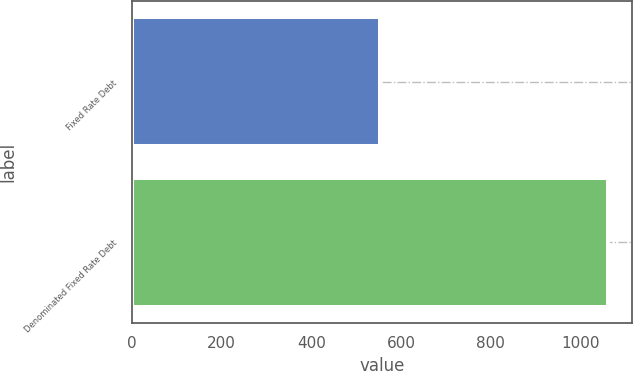<chart> <loc_0><loc_0><loc_500><loc_500><bar_chart><fcel>Fixed Rate Debt<fcel>Denominated Fixed Rate Debt<nl><fcel>552<fcel>1061<nl></chart> 